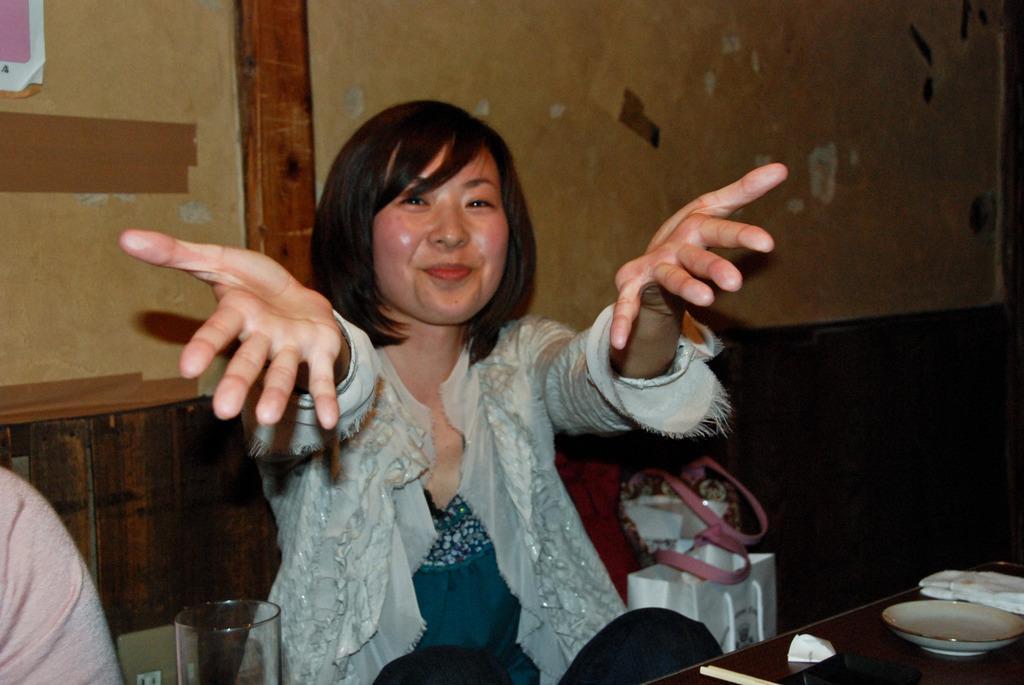Describe this image in one or two sentences. In this image, we can see a woman is sitting and smiling. At the bottom, we can see so many items. Background there is a wall, plaster, some poster. Left side of the image, we can see some cloth. Here there is a glass,carry bag, some object. This woman is stretching her hands. 